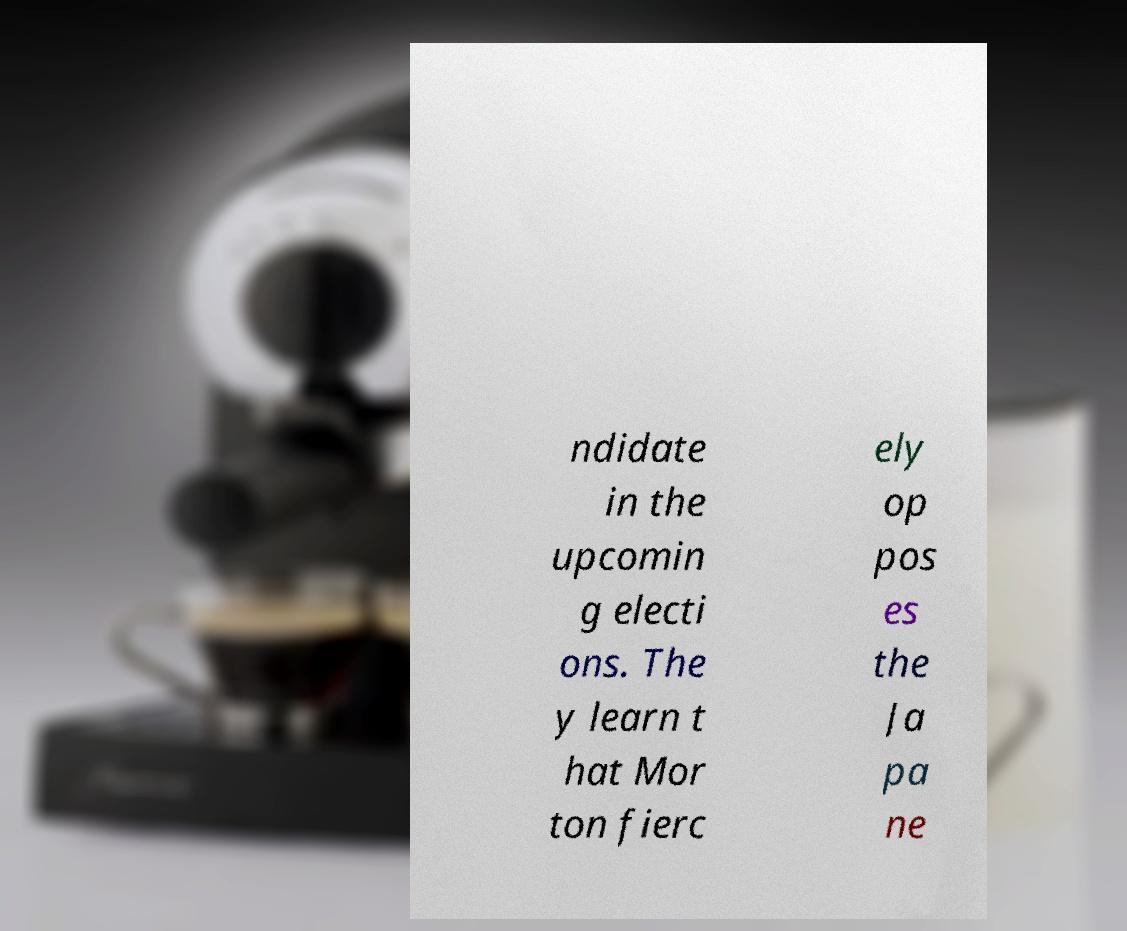Could you extract and type out the text from this image? ndidate in the upcomin g electi ons. The y learn t hat Mor ton fierc ely op pos es the Ja pa ne 